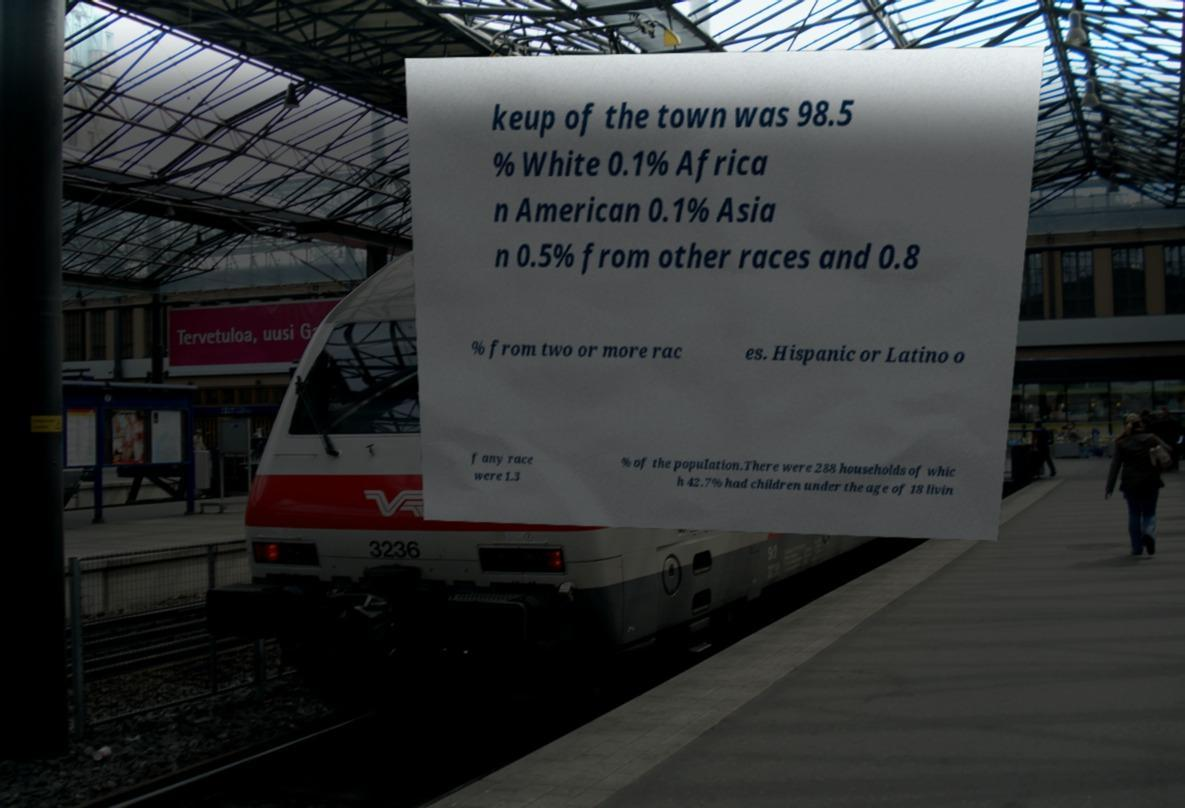Please identify and transcribe the text found in this image. keup of the town was 98.5 % White 0.1% Africa n American 0.1% Asia n 0.5% from other races and 0.8 % from two or more rac es. Hispanic or Latino o f any race were 1.3 % of the population.There were 288 households of whic h 42.7% had children under the age of 18 livin 